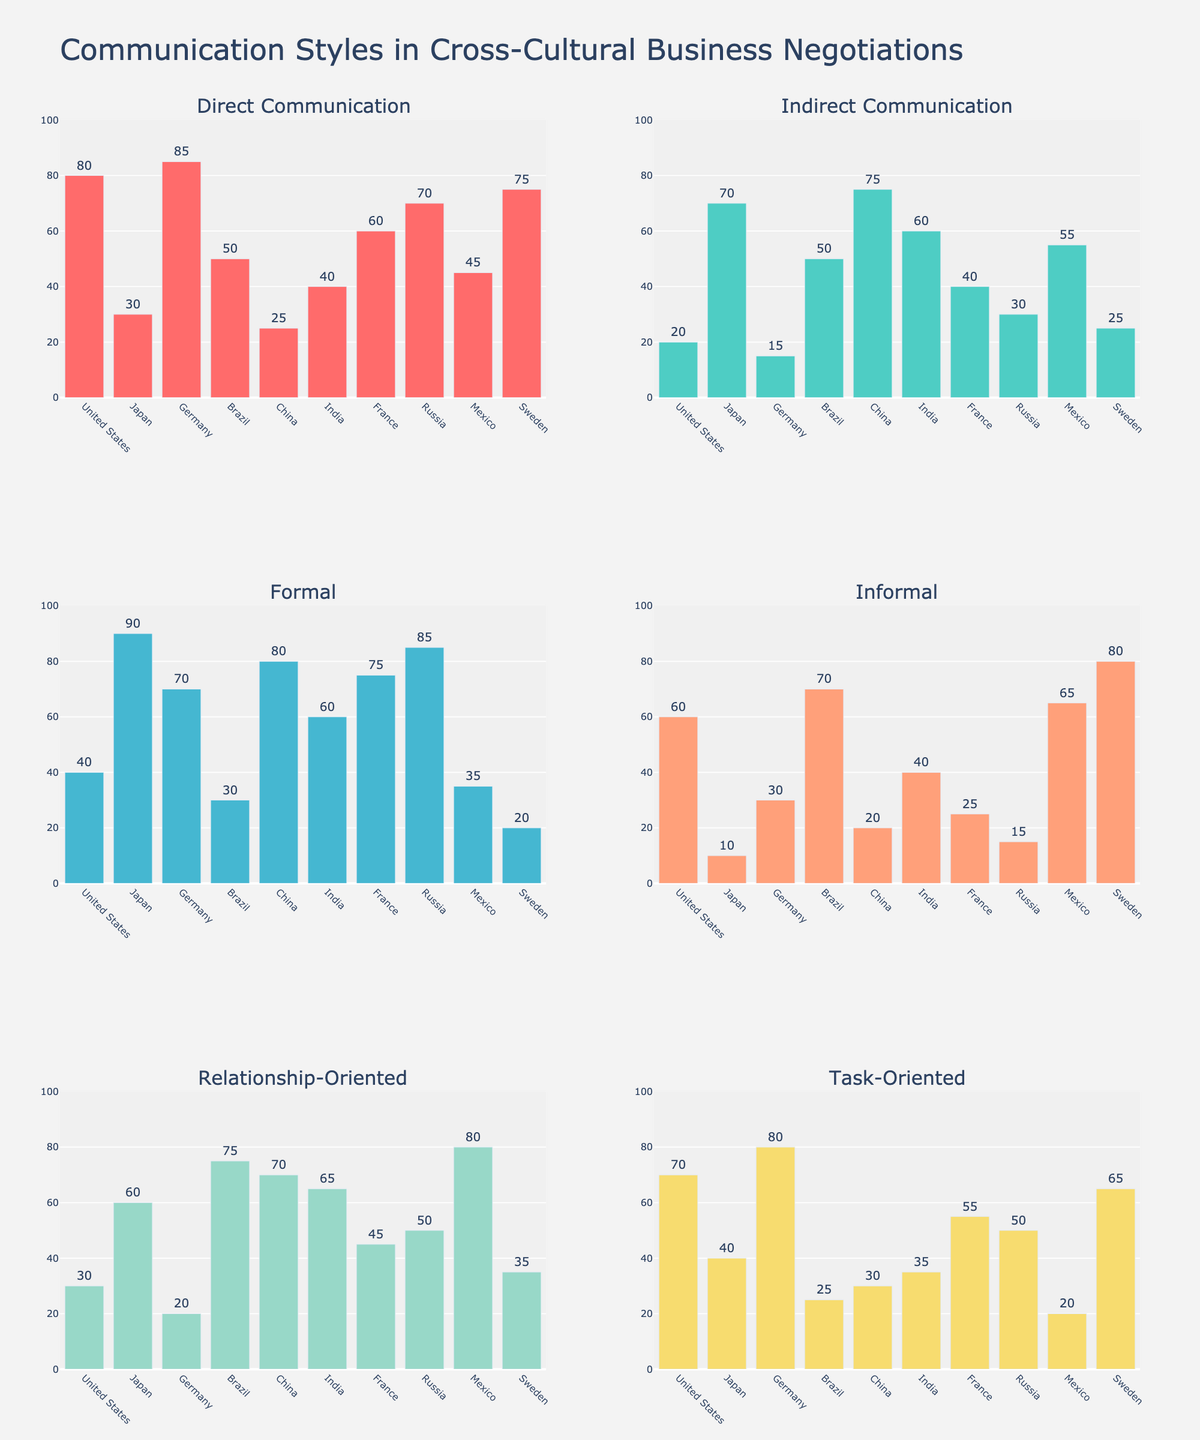Which culture uses direct communication the most? Look at the bar heights in the "Direct Communication" subplot. The United States has the tallest bar.
Answer: United States Which cultures have a higher value for informal communication than formal communication? Compare the bar heights in the "Informal" and "Formal" subplots. Brazil, Sweden, and Mexico have taller bars for informal communication.
Answer: Brazil, Sweden, Mexico What is the combined percentage for direct and task-oriented communication styles for Germany? Add the values for "Direct Communication" and "Task-Oriented" from the Germany bars. 85 + 80 = 165
Answer: 165 Which culture is the most relationship-oriented? Look for the highest bar in the "Relationship-Oriented" subplot. Mexico has the tallest bar.
Answer: Mexico How does Japan’s formal communication compare to its informal communication? Compare the bar heights for Japan in the "Formal" and "Informal" subplots. The "Formal" bar is significantly taller at 90 compared to "Informal" at 10.
Answer: Japan’s formal communication is much higher than its informal communication Which culture has the smallest difference between direct and indirect communication? Calculate the differences for each culture by comparing the heights of bars in the "Direct Communication" and "Indirect Communication" subplots. Brazil has the smallest difference at 50 - 50 = 0.
Answer: Brazil How do Russia and China compare in terms of formal communication? Compare the bar heights in the "Formal" subplot. Russia is higher at 85 compared to China at 80.
Answer: Russia has higher formal communication than China What is the average value of relationship-oriented communication across all cultures? Sum the "Relationship-Oriented" values (30+60+20+75+70+65+45+50+80+35 = 530) and divide by the number of cultures (10). 530/10 = 53
Answer: 53 Which culture uses indirect communication more than task-oriented communication? Compare the values across both subplots for each culture. China, India, and Brazil show higher values for "Indirect Communication" compared to "Task-Oriented."
Answer: China, India, Brazil Which style does India use least often? Identify the shortest bar for India across all subplots. "Informal" at 40 is the shortest value.
Answer: Informal 